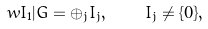Convert formula to latex. <formula><loc_0><loc_0><loc_500><loc_500>\ w { I _ { 1 } } | G = \oplus _ { j } I _ { j } , \quad I _ { j } \not = \{ 0 \} ,</formula> 